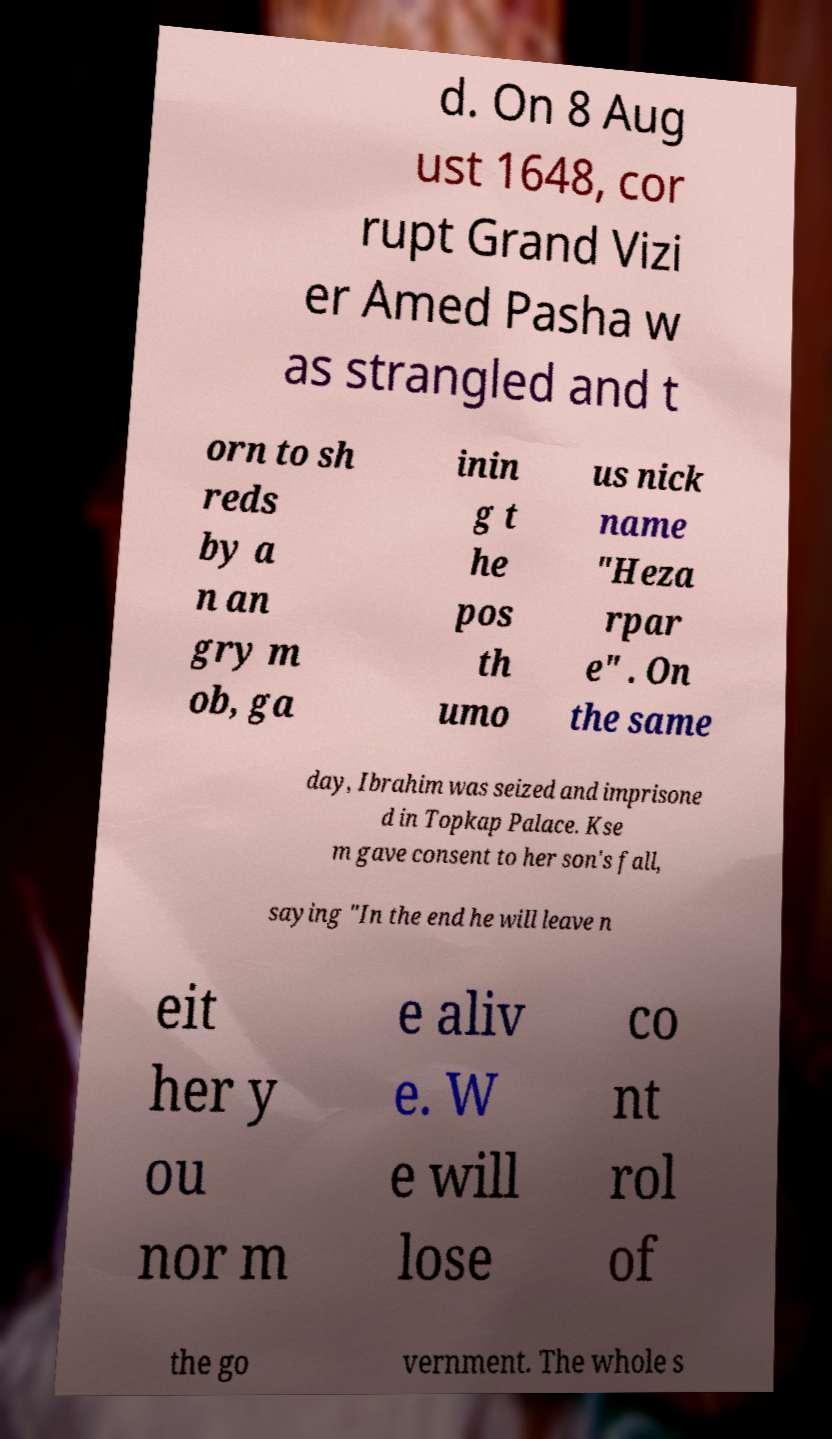Could you assist in decoding the text presented in this image and type it out clearly? d. On 8 Aug ust 1648, cor rupt Grand Vizi er Amed Pasha w as strangled and t orn to sh reds by a n an gry m ob, ga inin g t he pos th umo us nick name "Heza rpar e" . On the same day, Ibrahim was seized and imprisone d in Topkap Palace. Kse m gave consent to her son's fall, saying "In the end he will leave n eit her y ou nor m e aliv e. W e will lose co nt rol of the go vernment. The whole s 